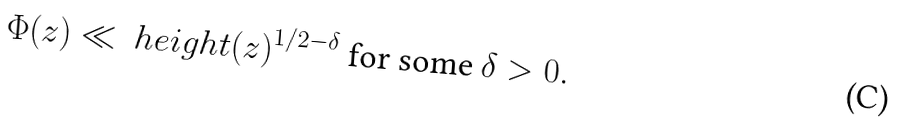Convert formula to latex. <formula><loc_0><loc_0><loc_500><loc_500>\Phi ( z ) \ll \ h e i g h t ( z ) ^ { 1 / 2 - \delta } \text { for some } \delta > 0 .</formula> 